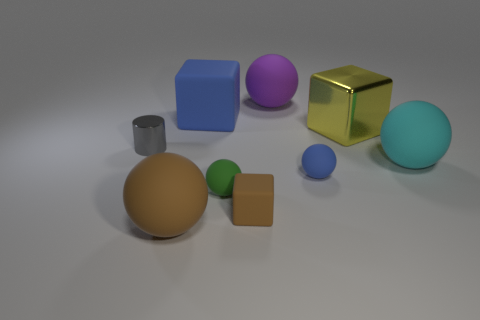Subtract all large blocks. How many blocks are left? 1 Subtract 1 spheres. How many spheres are left? 4 Subtract all purple balls. How many balls are left? 4 Add 1 large brown balls. How many objects exist? 10 Subtract all gray spheres. Subtract all brown blocks. How many spheres are left? 5 Subtract all cubes. How many objects are left? 6 Add 2 tiny purple metallic objects. How many tiny purple metallic objects exist? 2 Subtract 0 red balls. How many objects are left? 9 Subtract all large purple matte blocks. Subtract all matte things. How many objects are left? 2 Add 1 small shiny things. How many small shiny things are left? 2 